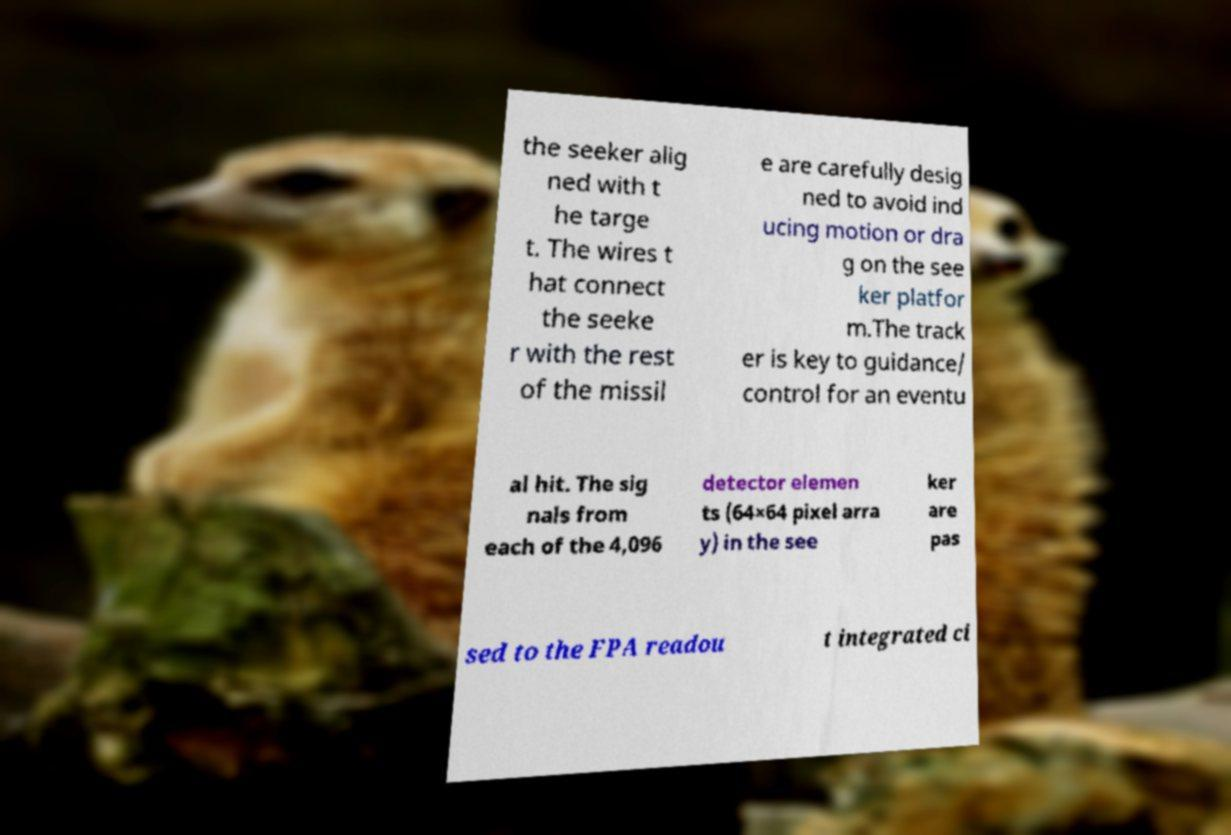Could you assist in decoding the text presented in this image and type it out clearly? the seeker alig ned with t he targe t. The wires t hat connect the seeke r with the rest of the missil e are carefully desig ned to avoid ind ucing motion or dra g on the see ker platfor m.The track er is key to guidance/ control for an eventu al hit. The sig nals from each of the 4,096 detector elemen ts (64×64 pixel arra y) in the see ker are pas sed to the FPA readou t integrated ci 